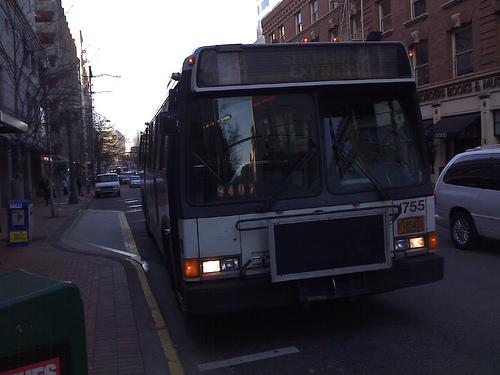What is the bus next to? curb 